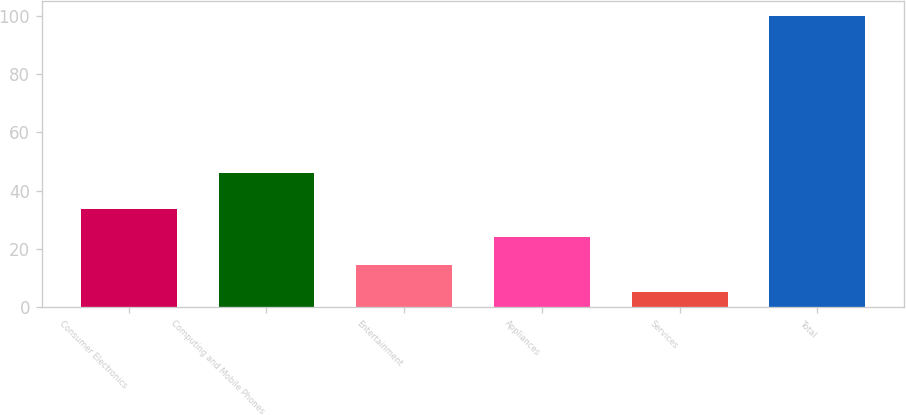<chart> <loc_0><loc_0><loc_500><loc_500><bar_chart><fcel>Consumer Electronics<fcel>Computing and Mobile Phones<fcel>Entertainment<fcel>Appliances<fcel>Services<fcel>Total<nl><fcel>33.5<fcel>46<fcel>14.5<fcel>24<fcel>5<fcel>100<nl></chart> 